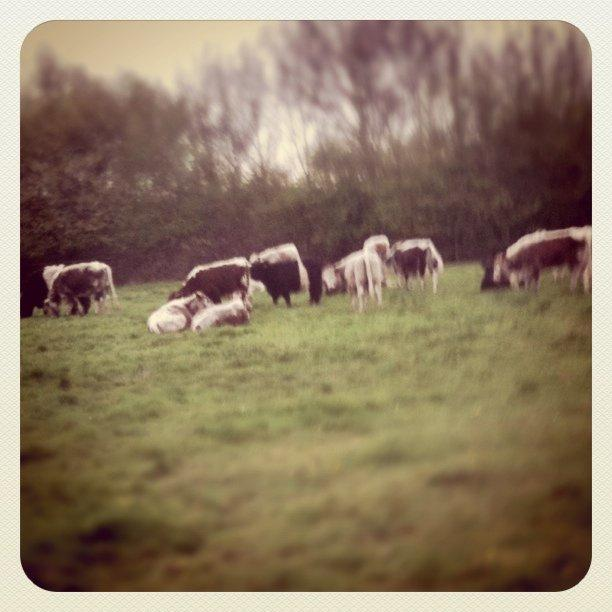What is wrong with this image? Please explain your reasoning. blurry. The image is blurry and makes for a bad photo. 